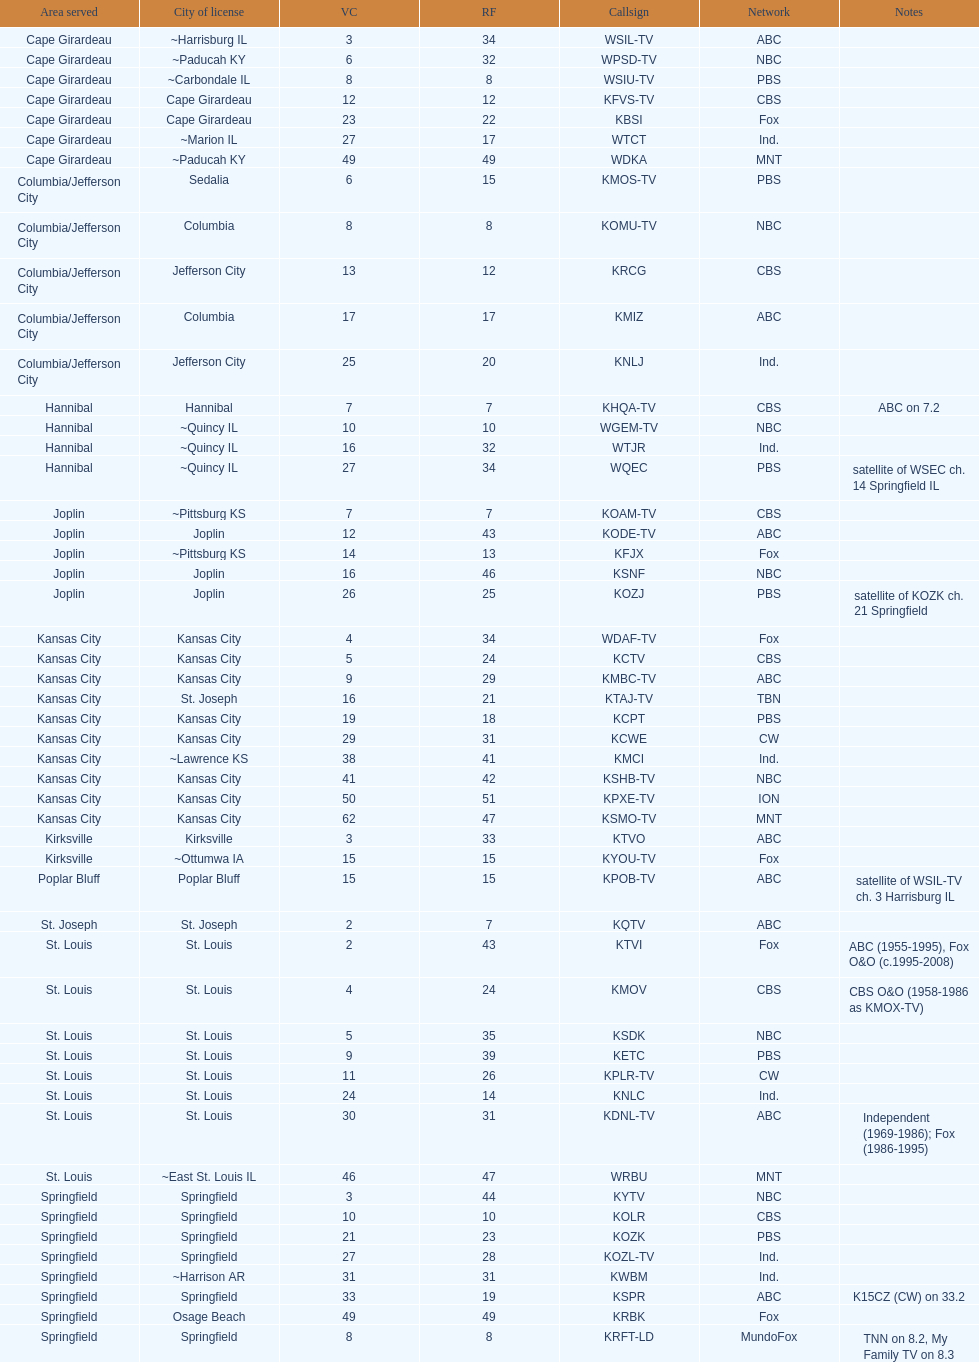How many people are involved with the cbs network? 7. 